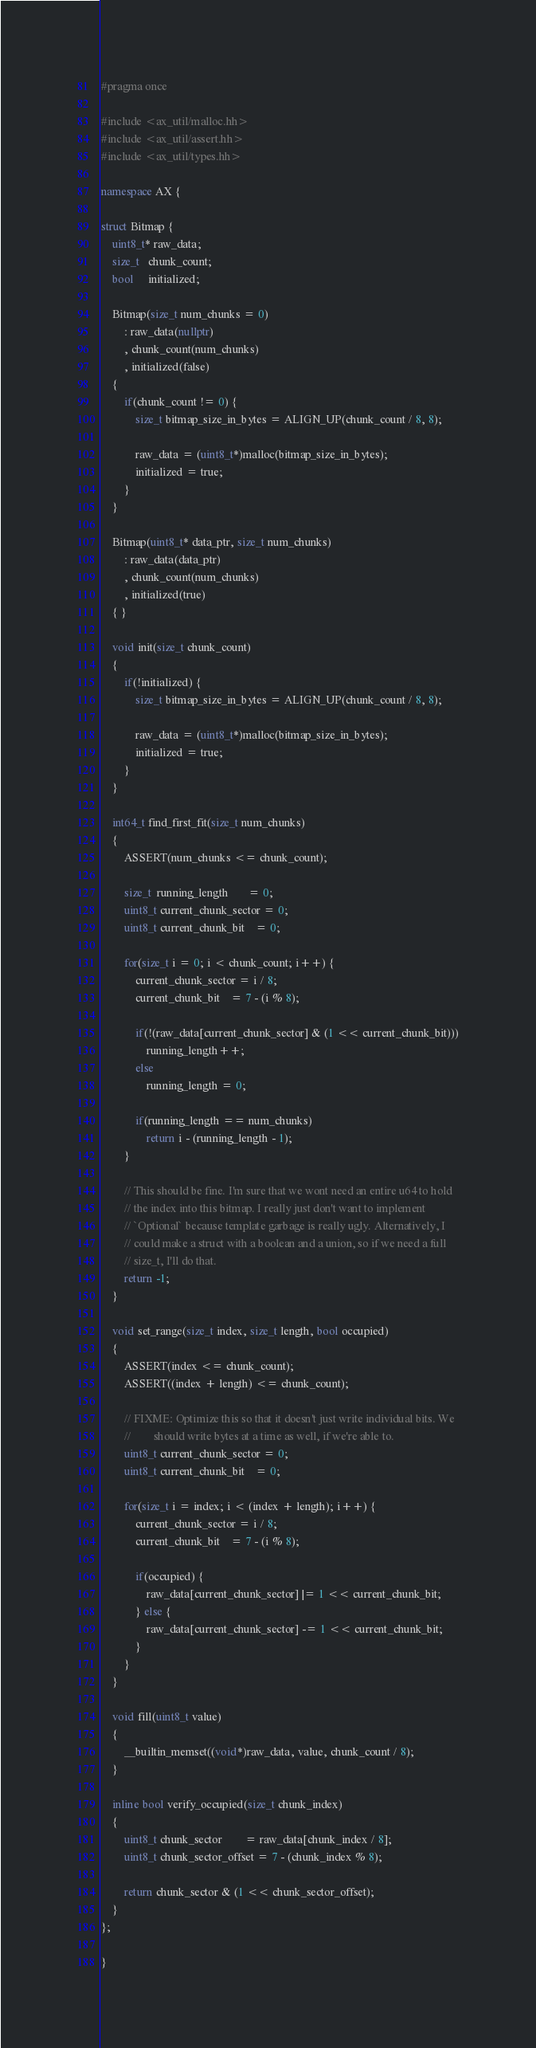<code> <loc_0><loc_0><loc_500><loc_500><_C++_>#pragma once

#include <ax_util/malloc.hh>
#include <ax_util/assert.hh>
#include <ax_util/types.hh>

namespace AX {

struct Bitmap {
	uint8_t* raw_data;
	size_t   chunk_count;
	bool     initialized;

	Bitmap(size_t num_chunks = 0)
		: raw_data(nullptr)
		, chunk_count(num_chunks)
		, initialized(false)
	{
		if(chunk_count != 0) {
			size_t bitmap_size_in_bytes = ALIGN_UP(chunk_count / 8, 8);

			raw_data = (uint8_t*)malloc(bitmap_size_in_bytes);
			initialized = true;
		}
	}

	Bitmap(uint8_t* data_ptr, size_t num_chunks)
		: raw_data(data_ptr)
		, chunk_count(num_chunks)
		, initialized(true)
	{ }

	void init(size_t chunk_count)
	{
		if(!initialized) {
			size_t bitmap_size_in_bytes = ALIGN_UP(chunk_count / 8, 8);

			raw_data = (uint8_t*)malloc(bitmap_size_in_bytes);
			initialized = true;
		}
	}

	int64_t find_first_fit(size_t num_chunks)
	{
		ASSERT(num_chunks <= chunk_count);

		size_t  running_length       = 0;
		uint8_t current_chunk_sector = 0;
		uint8_t current_chunk_bit    = 0;

		for(size_t i = 0; i < chunk_count; i++) {
			current_chunk_sector = i / 8;
			current_chunk_bit    = 7 - (i % 8);

			if(!(raw_data[current_chunk_sector] & (1 << current_chunk_bit)))
				running_length++;
			else
				running_length = 0;

			if(running_length == num_chunks)
				return i - (running_length - 1);
		}

		// This should be fine. I'm sure that we wont need an entire u64 to hold
		// the index into this bitmap. I really just don't want to implement
		// `Optional` because template garbage is really ugly. Alternatively, I
		// could make a struct with a boolean and a union, so if we need a full
		// size_t, I'll do that.
		return -1;
	}

	void set_range(size_t index, size_t length, bool occupied)
	{
		ASSERT(index <= chunk_count);
		ASSERT((index + length) <= chunk_count);

		// FIXME: Optimize this so that it doesn't just write individual bits. We
		//        should write bytes at a time as well, if we're able to.
		uint8_t current_chunk_sector = 0;
		uint8_t current_chunk_bit    = 0;

		for(size_t i = index; i < (index + length); i++) {
			current_chunk_sector = i / 8;
			current_chunk_bit    = 7 - (i % 8);

			if(occupied) {
				raw_data[current_chunk_sector] |= 1 << current_chunk_bit;
			} else {
				raw_data[current_chunk_sector] -= 1 << current_chunk_bit;
			}
		}
	}

	void fill(uint8_t value)
	{
		__builtin_memset((void*)raw_data, value, chunk_count / 8);
	}

	inline bool verify_occupied(size_t chunk_index)
	{
		uint8_t chunk_sector        = raw_data[chunk_index / 8];
		uint8_t chunk_sector_offset = 7 - (chunk_index % 8);

		return chunk_sector & (1 << chunk_sector_offset);
	}
};

}
</code> 